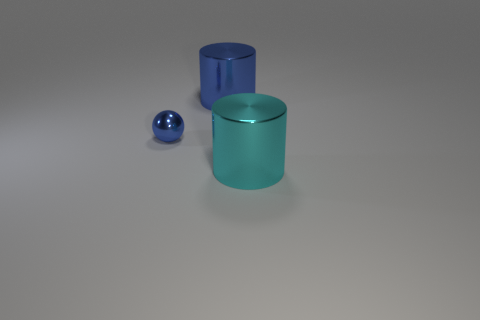Add 2 metal objects. How many objects exist? 5 Subtract all spheres. How many objects are left? 2 Add 3 small blue metal balls. How many small blue metal balls exist? 4 Subtract 0 gray spheres. How many objects are left? 3 Subtract all gray cylinders. Subtract all blue spheres. How many objects are left? 2 Add 1 tiny shiny things. How many tiny shiny things are left? 2 